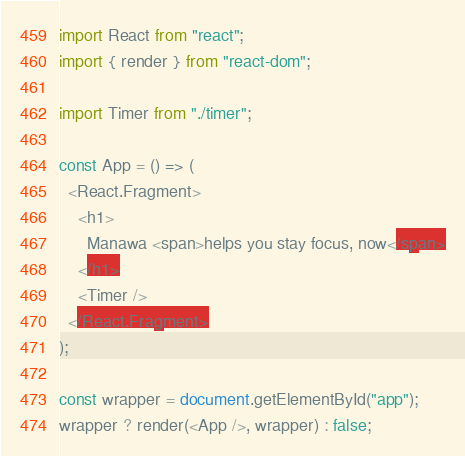<code> <loc_0><loc_0><loc_500><loc_500><_TypeScript_>import React from "react";
import { render } from "react-dom";

import Timer from "./timer";

const App = () => (
  <React.Fragment>
    <h1>
      Manawa <span>helps you stay focus, now</span>
    </h1>
    <Timer />
  </React.Fragment>
);

const wrapper = document.getElementById("app");
wrapper ? render(<App />, wrapper) : false;
</code> 